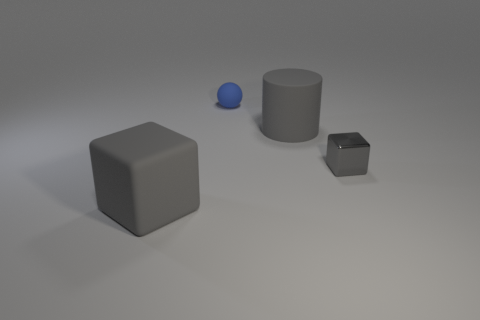How many tiny objects are in front of the large cylinder?
Ensure brevity in your answer.  1. Is there anything else that is the same size as the metal cube?
Make the answer very short. Yes. What color is the small ball that is made of the same material as the big cube?
Your answer should be compact. Blue. Is the shape of the tiny rubber object the same as the shiny thing?
Keep it short and to the point. No. What number of big gray matte things are in front of the small gray shiny cube and right of the big rubber cube?
Your answer should be very brief. 0. How many rubber objects are either gray cylinders or small gray spheres?
Keep it short and to the point. 1. What size is the gray rubber thing that is behind the block in front of the shiny thing?
Keep it short and to the point. Large. What is the material of the tiny object that is the same color as the large cylinder?
Provide a short and direct response. Metal. There is a big gray object in front of the large gray rubber object that is behind the big gray block; are there any gray cylinders that are in front of it?
Provide a short and direct response. No. Do the large thing behind the shiny thing and the small thing that is on the right side of the blue thing have the same material?
Your answer should be compact. No. 